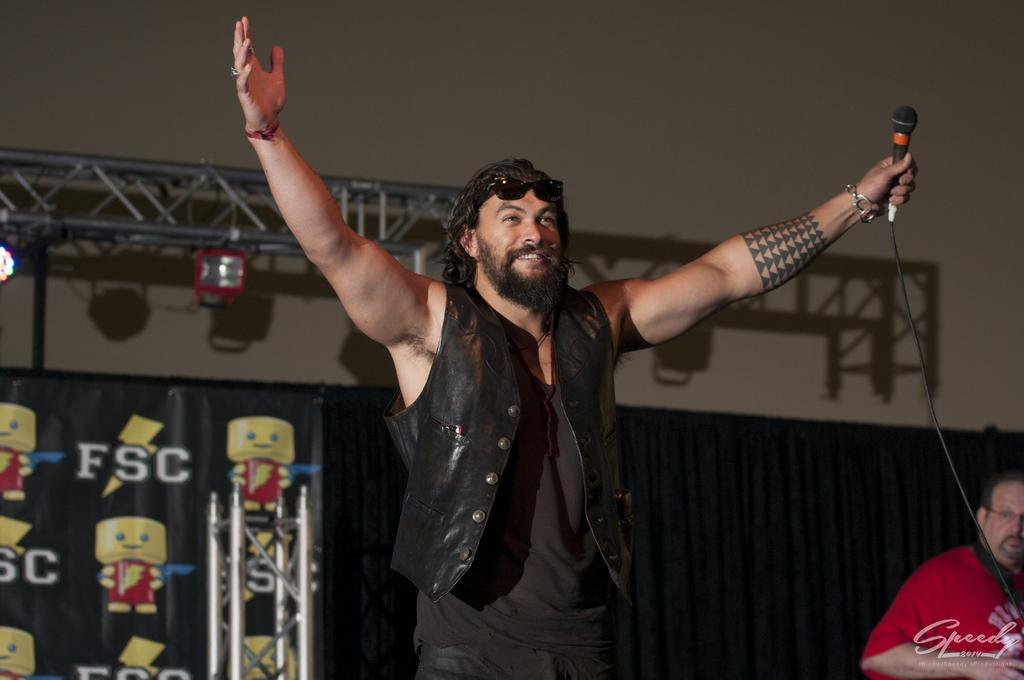What is the man in the image doing? The man is standing and holding a mic. How is the man's expression in the image? The man is smiling in the image. What can be seen in the background of the image? There is a wall, equipment, and another man in the background of the image. What type of dog can be seen holding a tray in the image? There is no dog or tray present in the image. What type of wine is the man drinking in the image? There is no wine present in the image; the man is holding a mic. 